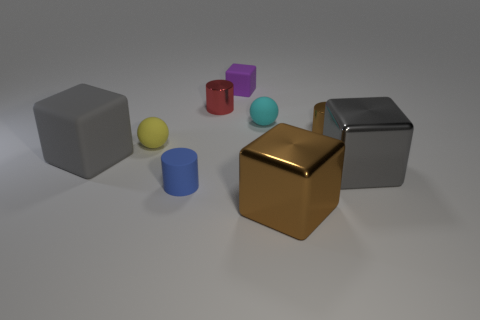There is a brown object that is the same shape as the small red shiny object; what is its size?
Provide a short and direct response. Small. Is the number of blue cylinders right of the big gray metallic object less than the number of small brown metal objects?
Ensure brevity in your answer.  Yes. Do the red shiny object and the yellow matte object have the same shape?
Offer a terse response. No. What color is the other small shiny thing that is the same shape as the red thing?
Give a very brief answer. Brown. What number of large rubber cubes are the same color as the small block?
Your response must be concise. 0. What number of objects are rubber things behind the gray metallic thing or purple spheres?
Make the answer very short. 4. How big is the gray object that is on the right side of the small purple object?
Give a very brief answer. Large. Is the number of cubes less than the number of things?
Offer a terse response. Yes. Are the big gray cube to the right of the red shiny object and the brown object behind the tiny yellow object made of the same material?
Your answer should be very brief. Yes. The brown shiny object in front of the brown shiny thing behind the big gray cube on the left side of the blue matte object is what shape?
Keep it short and to the point. Cube. 